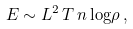Convert formula to latex. <formula><loc_0><loc_0><loc_500><loc_500>E \sim L ^ { 2 } \, T \, n \, { \log } \rho \, ,</formula> 